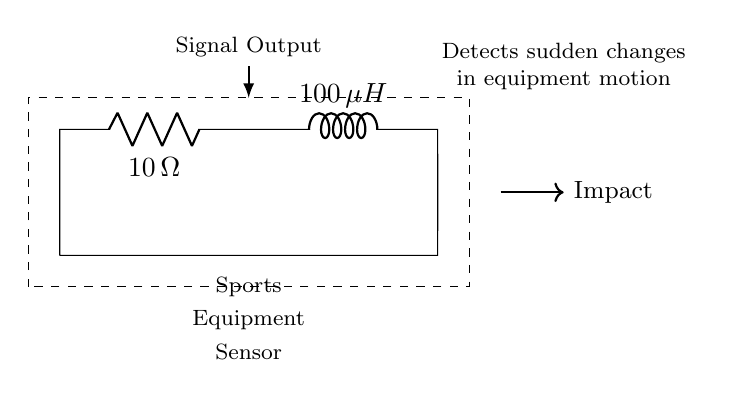What is the resistance value in the circuit? The circuit diagram indicates that the resistor is labeled with the value of ten ohms, which clearly shows the resistance.
Answer: ten ohms What is the inductance of the inductor? The inductor in the circuit is labeled with a value of one hundred microhenries, making it easy to identify its inductance.
Answer: one hundred microhenries How does the circuit respond to sudden impacts? The circuit is designed to detect sudden changes in equipment motion, indicating a direct response to impact events that can affect the sensor's output.
Answer: detects sudden changes What is the role of the resistor in this circuit? The resistor limits the current flowing through the circuit, which helps in managing the energy absorbed by the inductor during impact events, contributing to the overall response behavior of the sensor.
Answer: limits current What effect does increasing the inductor value have on the circuit's response? Increasing the inductance generally results in slower response times for the circuit, as it takes longer to reach a steady-state following an impact due to the inductor's opposition to changes in current.
Answer: slower response What is the purpose of the dashed rectangle in the diagram? The dashed rectangle encloses the components, signifying that they work together as a cohesive unit, specifically as a sports equipment sensor, clarifying their joint purpose in the diagram.
Answer: sports equipment sensor 